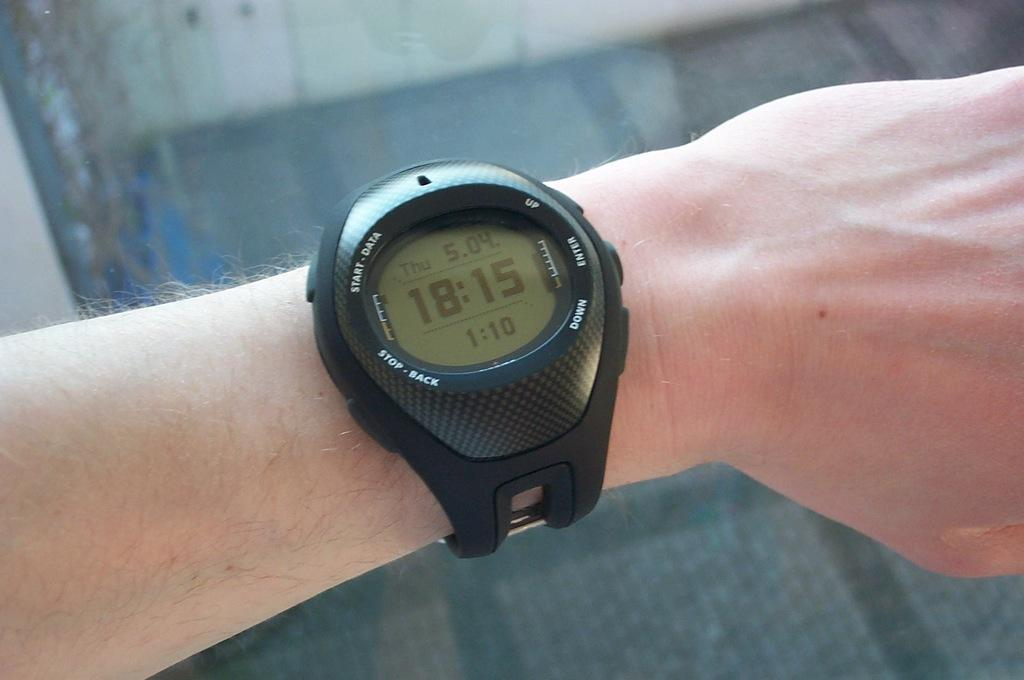<image>
Give a short and clear explanation of the subsequent image. a black wrist watch with the time 18:15 on it 